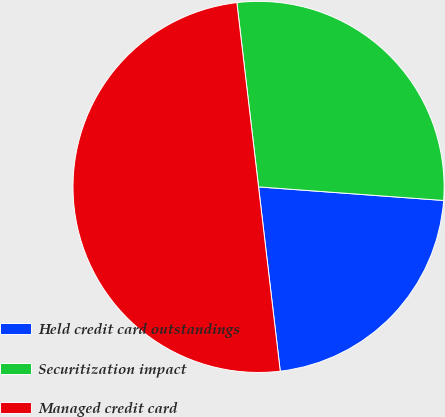Convert chart. <chart><loc_0><loc_0><loc_500><loc_500><pie_chart><fcel>Held credit card outstandings<fcel>Securitization impact<fcel>Managed credit card<nl><fcel>21.97%<fcel>28.03%<fcel>50.0%<nl></chart> 